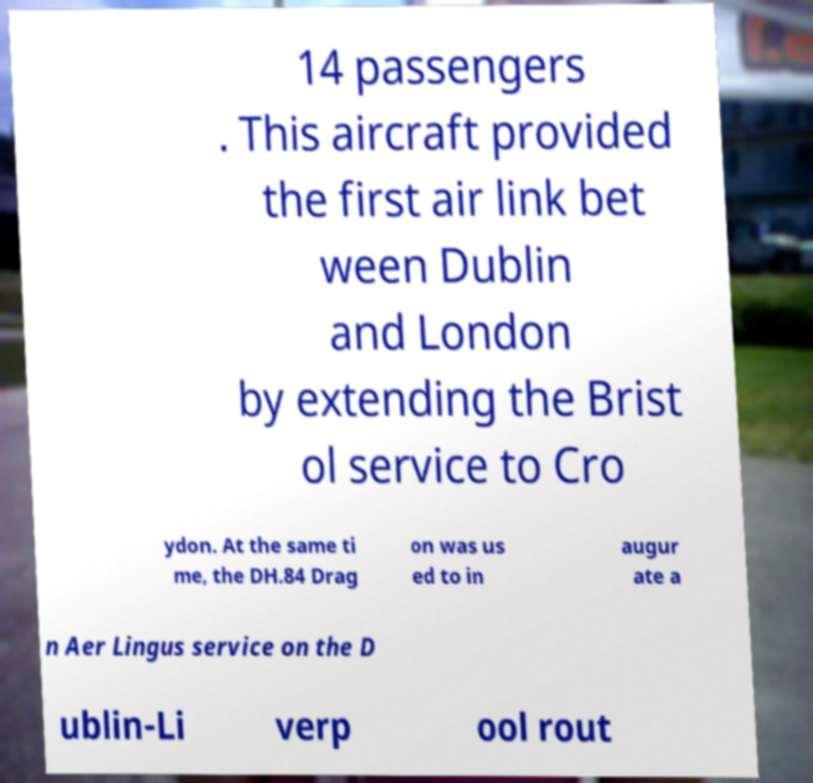For documentation purposes, I need the text within this image transcribed. Could you provide that? 14 passengers . This aircraft provided the first air link bet ween Dublin and London by extending the Brist ol service to Cro ydon. At the same ti me, the DH.84 Drag on was us ed to in augur ate a n Aer Lingus service on the D ublin-Li verp ool rout 